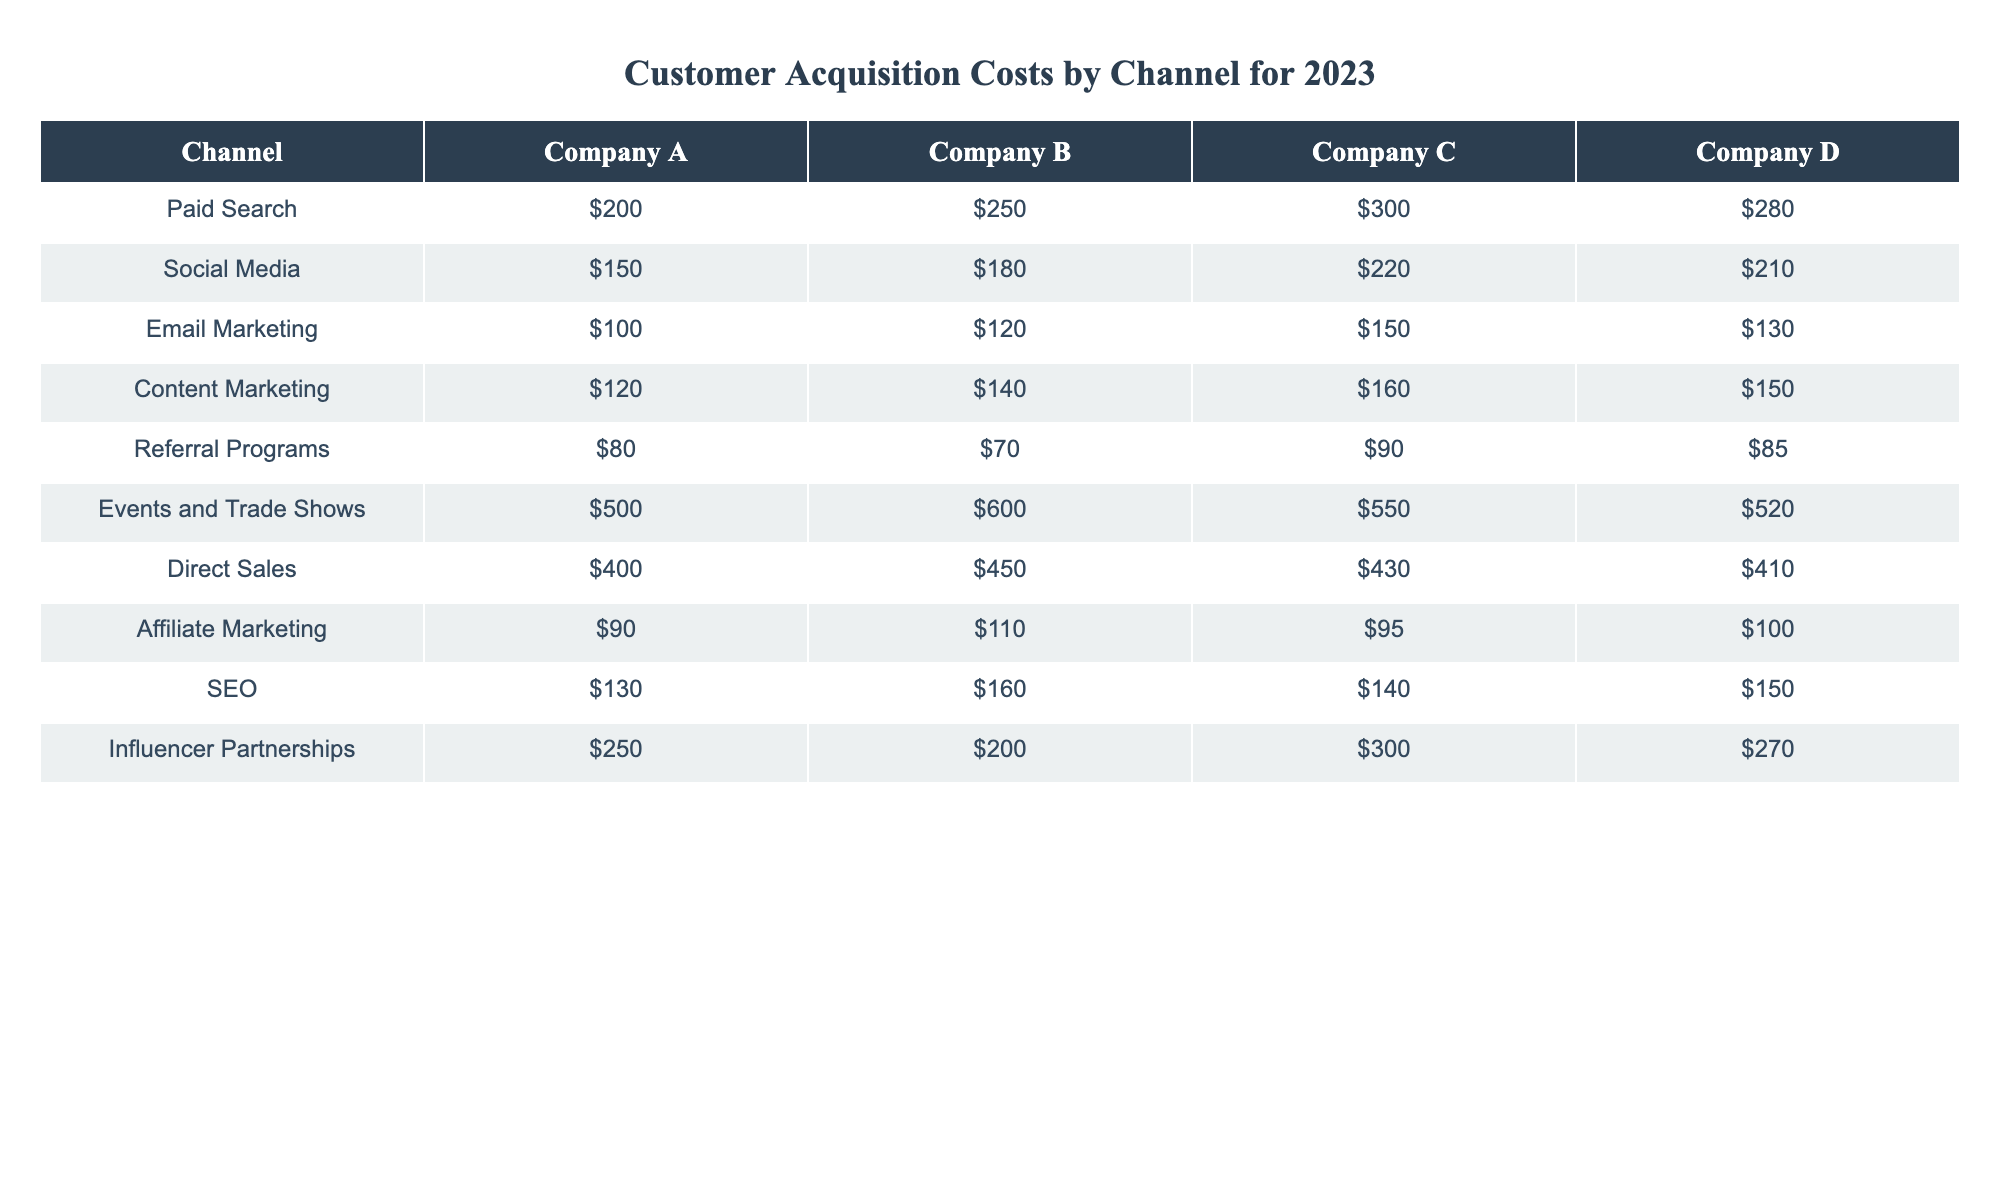What is the Customer Acquisition Cost for Company A using Paid Search? The table indicates the cost in the "Paid Search" row under "Company A," which shows $200.
Answer: $200 Which channel has the lowest Customer Acquisition Cost for Company C? By inspecting the costs for Company C across all channels, the lowest value is in "Referral Programs," which is $90.
Answer: $90 What is the average Customer Acquisition Cost for Company B across all channels? To calculate this, sum all values for Company B: $250 (Paid Search) + $180 (Social Media) + $120 (Email Marketing) + $140 (Content Marketing) + $70 (Referral Programs) + $600 (Events and Trade Shows) + $450 (Direct Sales) + $110 (Affiliate Marketing) + $160 (SEO) + $200 (Influencer Partnerships). The total is $2,180 divided by 10 channels equals $218.
Answer: $218 Is the Customer Acquisition Cost for Direct Sales higher than that for Events and Trade Shows for Company D? For Company D, Direct Sales costs $410 and Events and Trade Shows cost $520. Since $410 is less than $520, the statement is false.
Answer: No What is the difference in Customer Acquisition Costs between Email Marketing and Content Marketing for Company A? For Company A, Email Marketing is $100 and Content Marketing is $120. The difference is calculated as $120 - $100 = $20.
Answer: $20 Which channel has the highest Customer Acquisition Cost for Company D? By examining the values in the "Company D" column, the highest cost is in "Events and Trade Shows," which is $520.
Answer: $520 How much more does Company C spend on Influencer Partnerships compared to Affiliate Marketing? For Company C, the cost for Influencer Partnerships is $300 and for Affiliate Marketing is $95. The difference is $300 - $95 = $205.
Answer: $205 Are the Customer Acquisition Costs for SEO the same for Company B and Company D? Company B has a cost of $160 and Company D has a cost of $150 for SEO. Since $160 does not equal $150, the statement is false.
Answer: No What is the total Customer Acquisition Cost for Company A across all channels? The total is calculated by adding all costs: $200 (Paid Search) + $150 (Social Media) + $100 (Email Marketing) + $120 (Content Marketing) + $80 (Referral Programs) + $500 (Events and Trade Shows) + $400 (Direct Sales) + $90 (Affiliate Marketing) + $130 (SEO) + $250 (Influencer Partnerships) = $2,120.
Answer: $2,120 Which company's costs are consistently lower than those of Company D across all channels? Upon reviewing the table, Company B has consistently lower costs than Company D across all channels listed.
Answer: Company B 